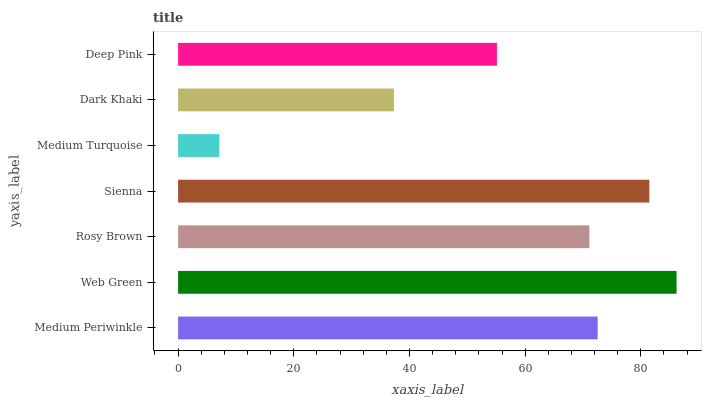Is Medium Turquoise the minimum?
Answer yes or no. Yes. Is Web Green the maximum?
Answer yes or no. Yes. Is Rosy Brown the minimum?
Answer yes or no. No. Is Rosy Brown the maximum?
Answer yes or no. No. Is Web Green greater than Rosy Brown?
Answer yes or no. Yes. Is Rosy Brown less than Web Green?
Answer yes or no. Yes. Is Rosy Brown greater than Web Green?
Answer yes or no. No. Is Web Green less than Rosy Brown?
Answer yes or no. No. Is Rosy Brown the high median?
Answer yes or no. Yes. Is Rosy Brown the low median?
Answer yes or no. Yes. Is Sienna the high median?
Answer yes or no. No. Is Medium Periwinkle the low median?
Answer yes or no. No. 